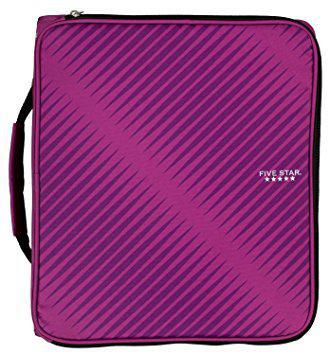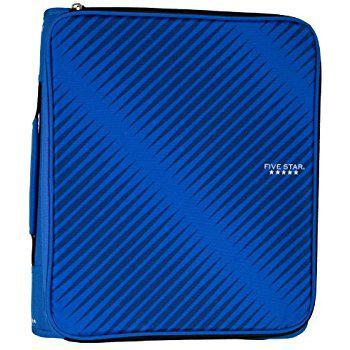The first image is the image on the left, the second image is the image on the right. Considering the images on both sides, is "The case in one of the images is blue." valid? Answer yes or no. Yes. 